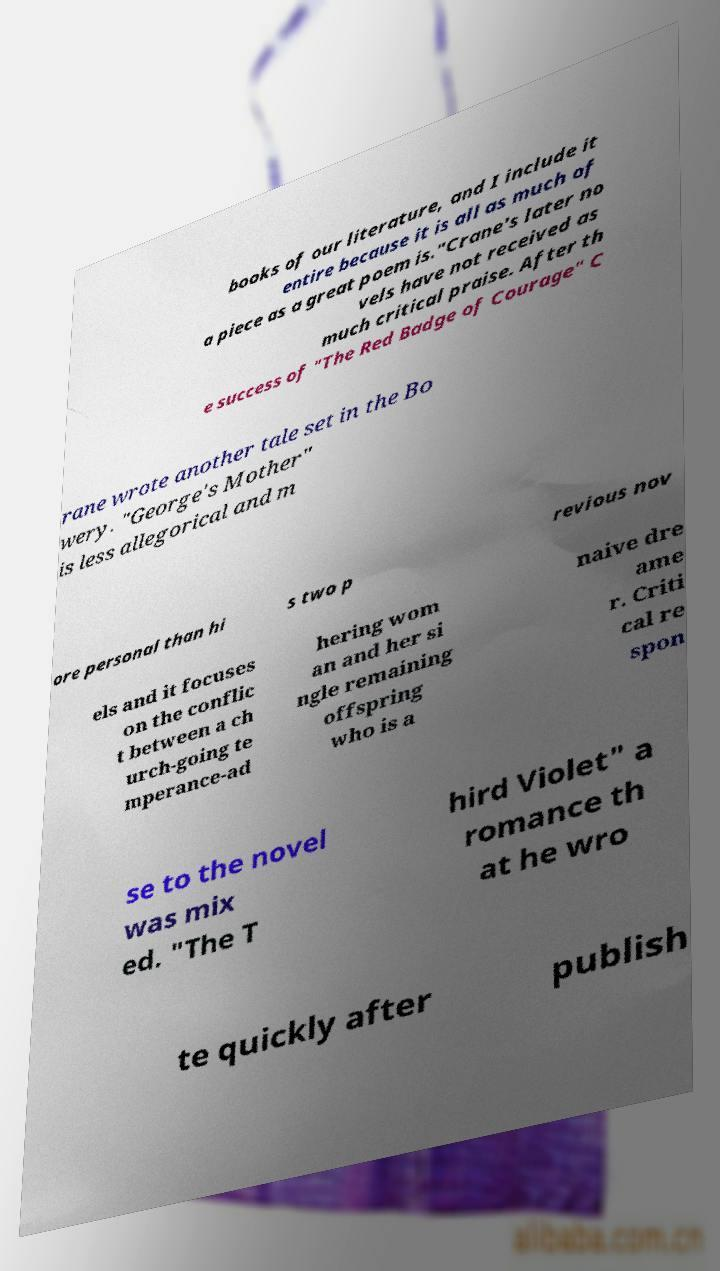I need the written content from this picture converted into text. Can you do that? books of our literature, and I include it entire because it is all as much of a piece as a great poem is."Crane's later no vels have not received as much critical praise. After th e success of "The Red Badge of Courage" C rane wrote another tale set in the Bo wery. "George's Mother" is less allegorical and m ore personal than hi s two p revious nov els and it focuses on the conflic t between a ch urch-going te mperance-ad hering wom an and her si ngle remaining offspring who is a naive dre ame r. Criti cal re spon se to the novel was mix ed. "The T hird Violet" a romance th at he wro te quickly after publish 